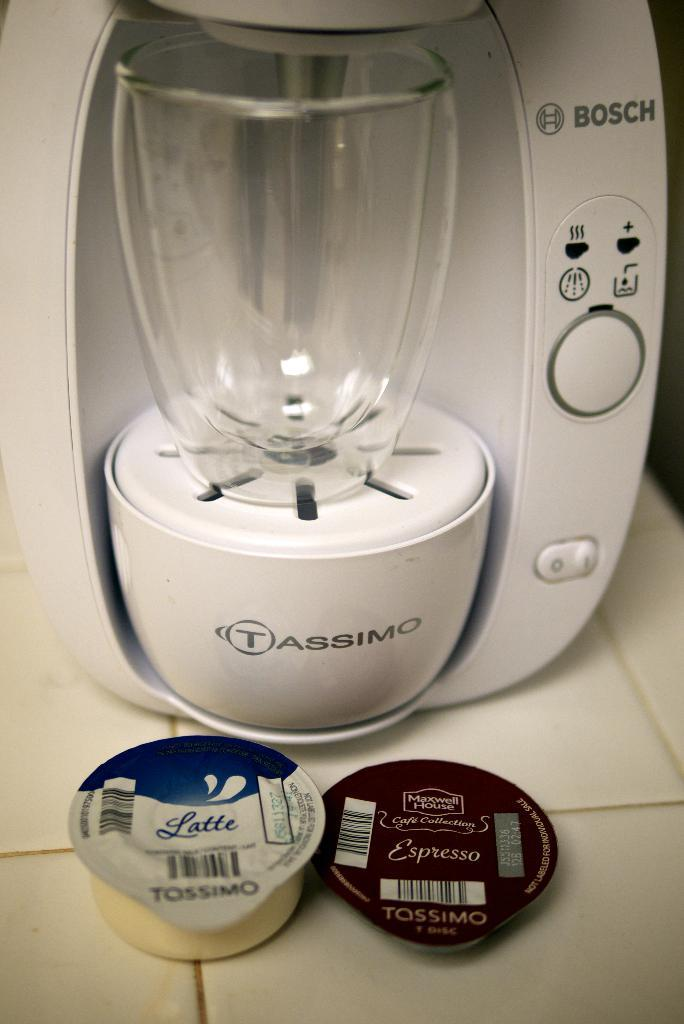Provide a one-sentence caption for the provided image. In front of the coffee maker are a latte pod and an espresso pod. 